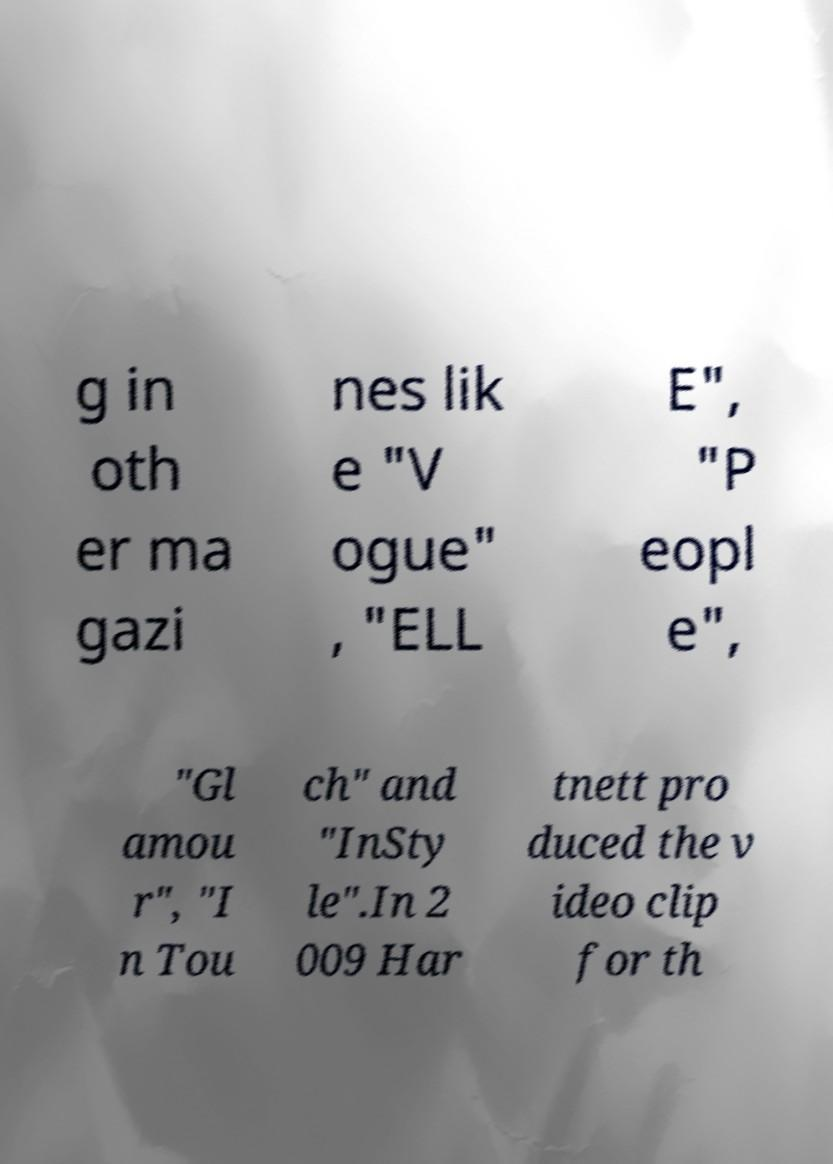Can you accurately transcribe the text from the provided image for me? g in oth er ma gazi nes lik e "V ogue" , "ELL E", "P eopl e", "Gl amou r", "I n Tou ch" and "InSty le".In 2 009 Har tnett pro duced the v ideo clip for th 